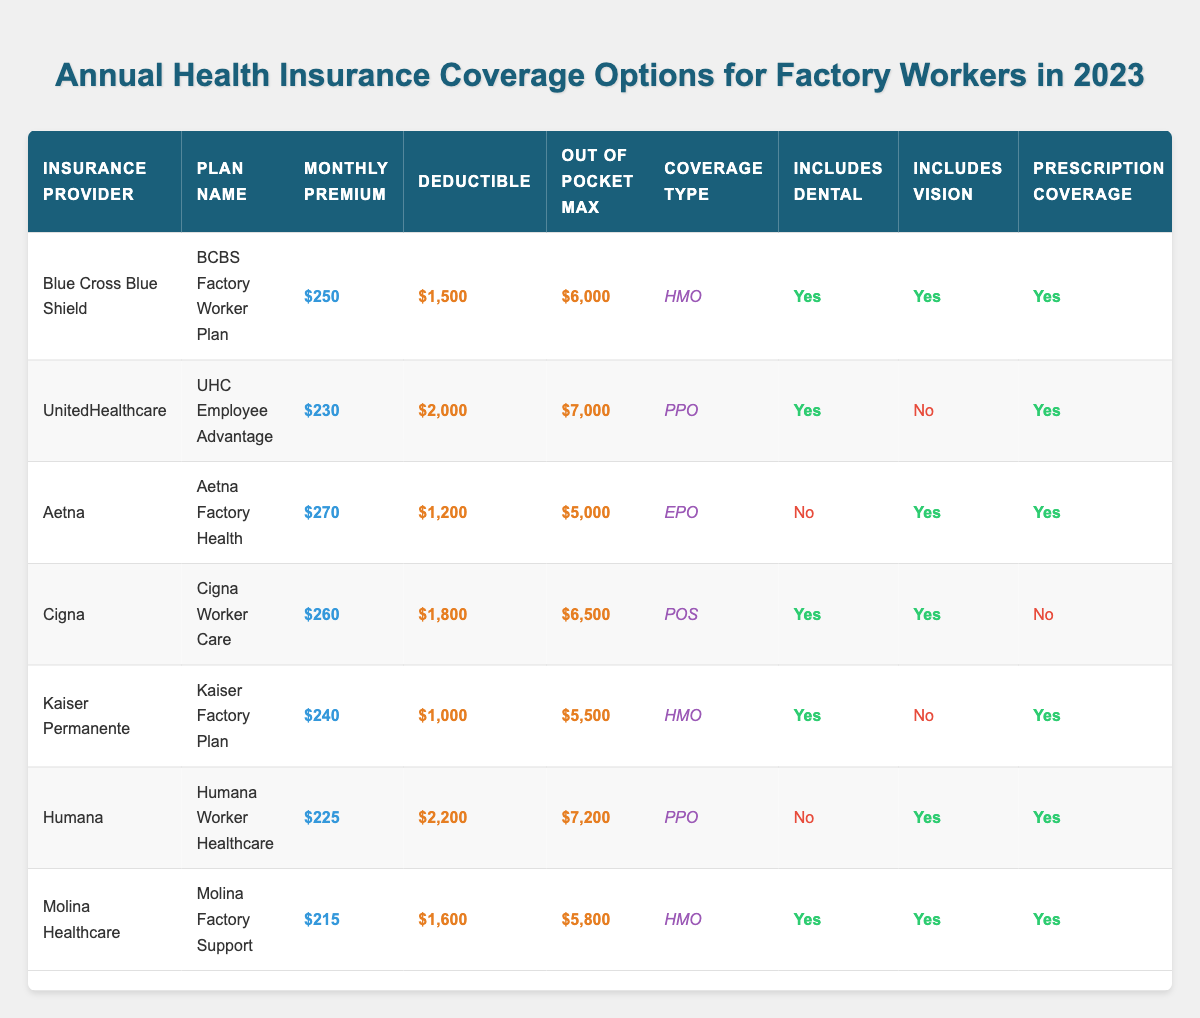What is the monthly premium for the Aetna Factory Health plan? The monthly premium for the Aetna Factory Health plan is listed in the table under the "Monthly Premium" column, which shows $270.
Answer: $270 Which plan has the highest deductible? The deductible amounts for each plan can be compared, and the UHC Employee Advantage plan has the highest deductible of $2,000 listed in the table.
Answer: $2,000 Does the Kaiser Factory Plan include vision coverage? The Kaiser Factory Plan's coverage details are shown in the table, and under the "Includes Vision" column, it indicates 'No,' meaning it does not include vision coverage.
Answer: No What is the total out-of-pocket maximum for all plans listed? To find the total out-of-pocket maximum, we sum the amounts for each plan: $6,000 + $7,000 + $5,000 + $6,500 + $5,500 + $7,200 + $5,800 = $43,000.
Answer: $43,000 Which insurance provider offers the most comprehensive plan including dental, vision, and prescription coverage? The Molina Factory Support plan from Molina Healthcare includes all three, as indicated by 'Yes' in the "Includes Dental," "Includes Vision," and "Prescription Coverage" columns.
Answer: Molina Healthcare What is the difference between the highest and lowest monthly premiums? The highest monthly premium is $270 (Aetna), and the lowest is $215 (Molina). The difference is calculated as $270 - $215 = $55.
Answer: $55 How many plans offer annual wellness visits? Checking the "Annual Wellness Visit" column, we find that all plans listed have 'Yes' indicated, totaling 7 plans that offer annual wellness visits.
Answer: 7 Which plan has the lowest out-of-pocket maximum? By examining the "Out of Pocket Max" column, we see that the Aetna Factory Health plan has the lowest out-of-pocket maximum of $5,000.
Answer: $5,000 Is the Humana plan a PPO type? The "Coverage Type" for Humana Worker Healthcare is specified as PPO in the table, confirming that it is indeed a PPO type.
Answer: Yes What is the average monthly premium of the plans? To calculate the average, sum the monthly premiums ($250 + $230 + $270 + $260 + $240 + $225 + $215 = $1,690) and divide by the number of plans (7). The average is $1,690 ÷ 7 = $241.43, which rounds to $241.
Answer: $241 